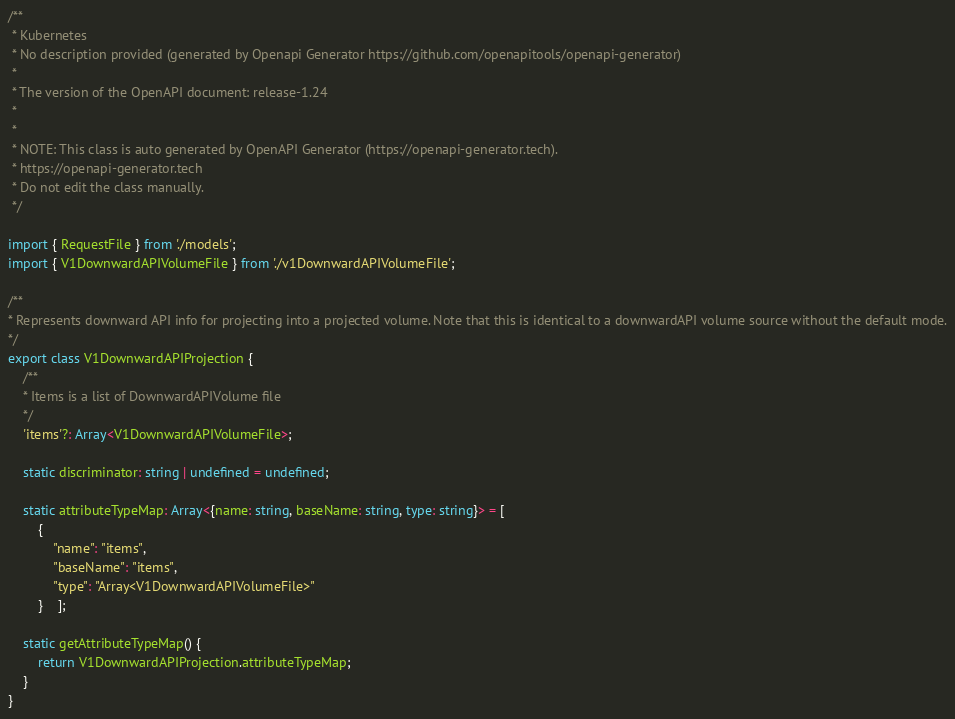<code> <loc_0><loc_0><loc_500><loc_500><_TypeScript_>/**
 * Kubernetes
 * No description provided (generated by Openapi Generator https://github.com/openapitools/openapi-generator)
 *
 * The version of the OpenAPI document: release-1.24
 * 
 *
 * NOTE: This class is auto generated by OpenAPI Generator (https://openapi-generator.tech).
 * https://openapi-generator.tech
 * Do not edit the class manually.
 */

import { RequestFile } from './models';
import { V1DownwardAPIVolumeFile } from './v1DownwardAPIVolumeFile';

/**
* Represents downward API info for projecting into a projected volume. Note that this is identical to a downwardAPI volume source without the default mode.
*/
export class V1DownwardAPIProjection {
    /**
    * Items is a list of DownwardAPIVolume file
    */
    'items'?: Array<V1DownwardAPIVolumeFile>;

    static discriminator: string | undefined = undefined;

    static attributeTypeMap: Array<{name: string, baseName: string, type: string}> = [
        {
            "name": "items",
            "baseName": "items",
            "type": "Array<V1DownwardAPIVolumeFile>"
        }    ];

    static getAttributeTypeMap() {
        return V1DownwardAPIProjection.attributeTypeMap;
    }
}

</code> 